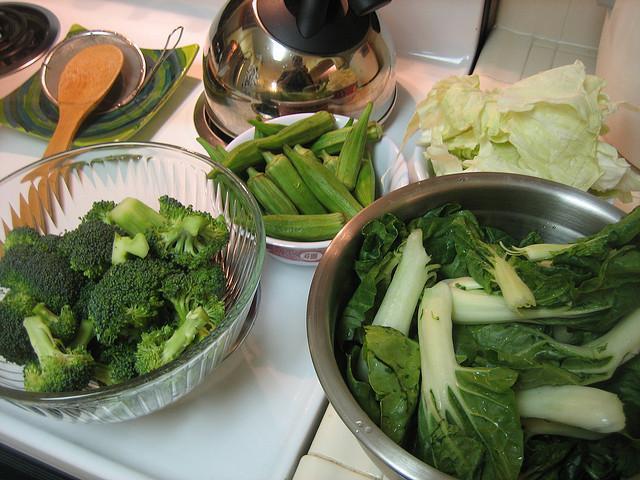What do all the foods being prepared have in common?
Choose the correct response, then elucidate: 'Answer: answer
Rationale: rationale.'
Options: Vegetables, meat, dessert, dairy. Answer: vegetables.
Rationale: A table has several bowls filled with green leafy food items. vegetables are often green and leafy. 